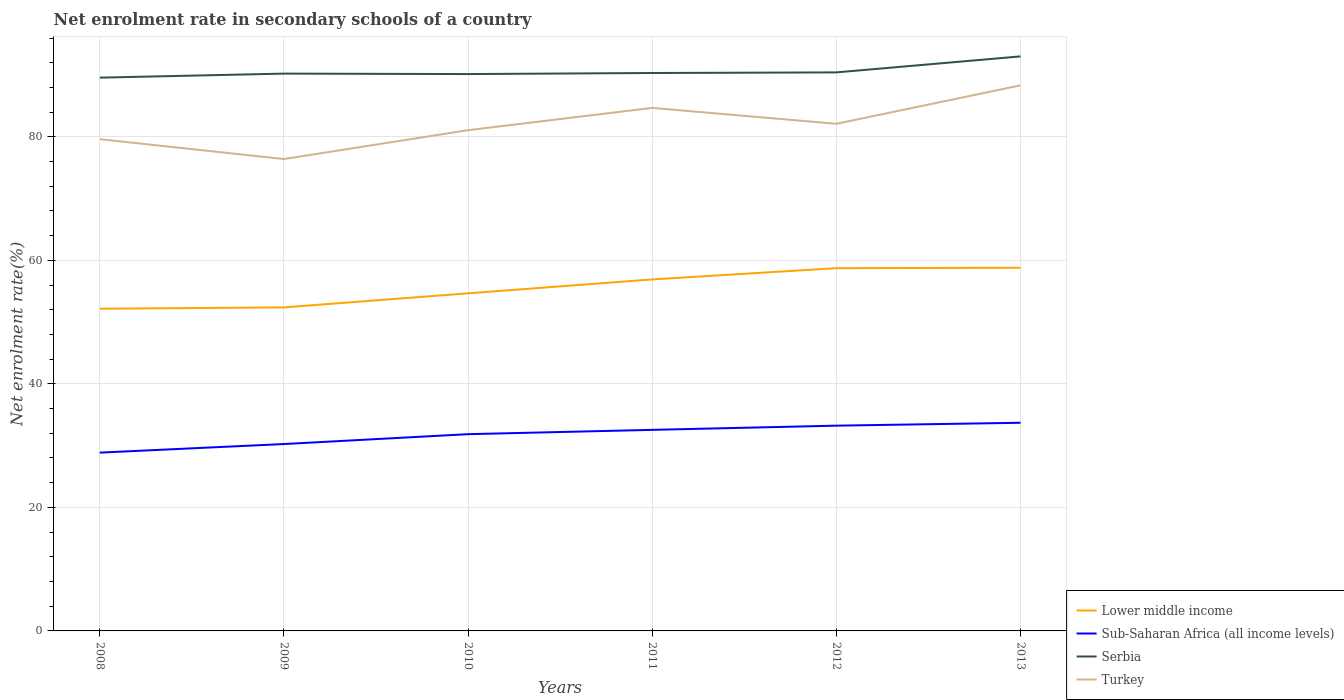Does the line corresponding to Sub-Saharan Africa (all income levels) intersect with the line corresponding to Turkey?
Offer a terse response. No. Is the number of lines equal to the number of legend labels?
Provide a short and direct response. Yes. Across all years, what is the maximum net enrolment rate in secondary schools in Sub-Saharan Africa (all income levels)?
Offer a terse response. 28.87. In which year was the net enrolment rate in secondary schools in Serbia maximum?
Make the answer very short. 2008. What is the total net enrolment rate in secondary schools in Turkey in the graph?
Ensure brevity in your answer.  -1.46. What is the difference between the highest and the second highest net enrolment rate in secondary schools in Serbia?
Offer a very short reply. 3.44. How many lines are there?
Offer a terse response. 4. How many years are there in the graph?
Ensure brevity in your answer.  6. What is the difference between two consecutive major ticks on the Y-axis?
Your response must be concise. 20. Are the values on the major ticks of Y-axis written in scientific E-notation?
Give a very brief answer. No. Does the graph contain any zero values?
Keep it short and to the point. No. How many legend labels are there?
Provide a short and direct response. 4. How are the legend labels stacked?
Ensure brevity in your answer.  Vertical. What is the title of the graph?
Your answer should be compact. Net enrolment rate in secondary schools of a country. What is the label or title of the Y-axis?
Provide a succinct answer. Net enrolment rate(%). What is the Net enrolment rate(%) in Lower middle income in 2008?
Give a very brief answer. 52.17. What is the Net enrolment rate(%) in Sub-Saharan Africa (all income levels) in 2008?
Provide a short and direct response. 28.87. What is the Net enrolment rate(%) of Serbia in 2008?
Keep it short and to the point. 89.59. What is the Net enrolment rate(%) in Turkey in 2008?
Provide a succinct answer. 79.62. What is the Net enrolment rate(%) of Lower middle income in 2009?
Your response must be concise. 52.39. What is the Net enrolment rate(%) of Sub-Saharan Africa (all income levels) in 2009?
Your response must be concise. 30.26. What is the Net enrolment rate(%) of Serbia in 2009?
Your answer should be very brief. 90.24. What is the Net enrolment rate(%) in Turkey in 2009?
Your answer should be compact. 76.41. What is the Net enrolment rate(%) in Lower middle income in 2010?
Offer a terse response. 54.67. What is the Net enrolment rate(%) in Sub-Saharan Africa (all income levels) in 2010?
Offer a very short reply. 31.86. What is the Net enrolment rate(%) of Serbia in 2010?
Your answer should be compact. 90.17. What is the Net enrolment rate(%) in Turkey in 2010?
Ensure brevity in your answer.  81.08. What is the Net enrolment rate(%) of Lower middle income in 2011?
Ensure brevity in your answer.  56.92. What is the Net enrolment rate(%) in Sub-Saharan Africa (all income levels) in 2011?
Keep it short and to the point. 32.55. What is the Net enrolment rate(%) in Serbia in 2011?
Offer a terse response. 90.34. What is the Net enrolment rate(%) of Turkey in 2011?
Your answer should be compact. 84.69. What is the Net enrolment rate(%) in Lower middle income in 2012?
Make the answer very short. 58.74. What is the Net enrolment rate(%) in Sub-Saharan Africa (all income levels) in 2012?
Ensure brevity in your answer.  33.24. What is the Net enrolment rate(%) in Serbia in 2012?
Offer a terse response. 90.44. What is the Net enrolment rate(%) of Turkey in 2012?
Make the answer very short. 82.11. What is the Net enrolment rate(%) of Lower middle income in 2013?
Make the answer very short. 58.8. What is the Net enrolment rate(%) in Sub-Saharan Africa (all income levels) in 2013?
Your answer should be very brief. 33.71. What is the Net enrolment rate(%) in Serbia in 2013?
Give a very brief answer. 93.03. What is the Net enrolment rate(%) of Turkey in 2013?
Offer a very short reply. 88.34. Across all years, what is the maximum Net enrolment rate(%) of Lower middle income?
Offer a terse response. 58.8. Across all years, what is the maximum Net enrolment rate(%) of Sub-Saharan Africa (all income levels)?
Keep it short and to the point. 33.71. Across all years, what is the maximum Net enrolment rate(%) of Serbia?
Make the answer very short. 93.03. Across all years, what is the maximum Net enrolment rate(%) of Turkey?
Your answer should be compact. 88.34. Across all years, what is the minimum Net enrolment rate(%) in Lower middle income?
Give a very brief answer. 52.17. Across all years, what is the minimum Net enrolment rate(%) of Sub-Saharan Africa (all income levels)?
Make the answer very short. 28.87. Across all years, what is the minimum Net enrolment rate(%) of Serbia?
Offer a terse response. 89.59. Across all years, what is the minimum Net enrolment rate(%) in Turkey?
Provide a short and direct response. 76.41. What is the total Net enrolment rate(%) of Lower middle income in the graph?
Provide a succinct answer. 333.68. What is the total Net enrolment rate(%) of Sub-Saharan Africa (all income levels) in the graph?
Offer a very short reply. 190.48. What is the total Net enrolment rate(%) in Serbia in the graph?
Your answer should be very brief. 543.8. What is the total Net enrolment rate(%) in Turkey in the graph?
Provide a succinct answer. 492.26. What is the difference between the Net enrolment rate(%) in Lower middle income in 2008 and that in 2009?
Your answer should be compact. -0.22. What is the difference between the Net enrolment rate(%) of Sub-Saharan Africa (all income levels) in 2008 and that in 2009?
Provide a short and direct response. -1.39. What is the difference between the Net enrolment rate(%) in Serbia in 2008 and that in 2009?
Your answer should be compact. -0.65. What is the difference between the Net enrolment rate(%) of Turkey in 2008 and that in 2009?
Provide a succinct answer. 3.22. What is the difference between the Net enrolment rate(%) in Lower middle income in 2008 and that in 2010?
Your response must be concise. -2.49. What is the difference between the Net enrolment rate(%) in Sub-Saharan Africa (all income levels) in 2008 and that in 2010?
Make the answer very short. -2.99. What is the difference between the Net enrolment rate(%) of Serbia in 2008 and that in 2010?
Ensure brevity in your answer.  -0.58. What is the difference between the Net enrolment rate(%) of Turkey in 2008 and that in 2010?
Provide a short and direct response. -1.46. What is the difference between the Net enrolment rate(%) of Lower middle income in 2008 and that in 2011?
Give a very brief answer. -4.75. What is the difference between the Net enrolment rate(%) of Sub-Saharan Africa (all income levels) in 2008 and that in 2011?
Ensure brevity in your answer.  -3.69. What is the difference between the Net enrolment rate(%) in Serbia in 2008 and that in 2011?
Provide a short and direct response. -0.75. What is the difference between the Net enrolment rate(%) of Turkey in 2008 and that in 2011?
Give a very brief answer. -5.07. What is the difference between the Net enrolment rate(%) of Lower middle income in 2008 and that in 2012?
Ensure brevity in your answer.  -6.57. What is the difference between the Net enrolment rate(%) in Sub-Saharan Africa (all income levels) in 2008 and that in 2012?
Your response must be concise. -4.37. What is the difference between the Net enrolment rate(%) of Serbia in 2008 and that in 2012?
Provide a succinct answer. -0.85. What is the difference between the Net enrolment rate(%) in Turkey in 2008 and that in 2012?
Your response must be concise. -2.49. What is the difference between the Net enrolment rate(%) in Lower middle income in 2008 and that in 2013?
Keep it short and to the point. -6.63. What is the difference between the Net enrolment rate(%) in Sub-Saharan Africa (all income levels) in 2008 and that in 2013?
Your answer should be compact. -4.84. What is the difference between the Net enrolment rate(%) in Serbia in 2008 and that in 2013?
Provide a succinct answer. -3.44. What is the difference between the Net enrolment rate(%) in Turkey in 2008 and that in 2013?
Make the answer very short. -8.72. What is the difference between the Net enrolment rate(%) in Lower middle income in 2009 and that in 2010?
Ensure brevity in your answer.  -2.28. What is the difference between the Net enrolment rate(%) in Sub-Saharan Africa (all income levels) in 2009 and that in 2010?
Offer a terse response. -1.6. What is the difference between the Net enrolment rate(%) of Serbia in 2009 and that in 2010?
Your response must be concise. 0.07. What is the difference between the Net enrolment rate(%) of Turkey in 2009 and that in 2010?
Offer a very short reply. -4.67. What is the difference between the Net enrolment rate(%) in Lower middle income in 2009 and that in 2011?
Provide a short and direct response. -4.53. What is the difference between the Net enrolment rate(%) in Sub-Saharan Africa (all income levels) in 2009 and that in 2011?
Provide a succinct answer. -2.29. What is the difference between the Net enrolment rate(%) of Serbia in 2009 and that in 2011?
Your answer should be compact. -0.1. What is the difference between the Net enrolment rate(%) of Turkey in 2009 and that in 2011?
Offer a terse response. -8.28. What is the difference between the Net enrolment rate(%) in Lower middle income in 2009 and that in 2012?
Provide a succinct answer. -6.35. What is the difference between the Net enrolment rate(%) of Sub-Saharan Africa (all income levels) in 2009 and that in 2012?
Give a very brief answer. -2.98. What is the difference between the Net enrolment rate(%) in Serbia in 2009 and that in 2012?
Give a very brief answer. -0.2. What is the difference between the Net enrolment rate(%) of Turkey in 2009 and that in 2012?
Provide a succinct answer. -5.71. What is the difference between the Net enrolment rate(%) of Lower middle income in 2009 and that in 2013?
Make the answer very short. -6.42. What is the difference between the Net enrolment rate(%) of Sub-Saharan Africa (all income levels) in 2009 and that in 2013?
Make the answer very short. -3.45. What is the difference between the Net enrolment rate(%) in Serbia in 2009 and that in 2013?
Provide a succinct answer. -2.79. What is the difference between the Net enrolment rate(%) of Turkey in 2009 and that in 2013?
Provide a short and direct response. -11.94. What is the difference between the Net enrolment rate(%) in Lower middle income in 2010 and that in 2011?
Ensure brevity in your answer.  -2.25. What is the difference between the Net enrolment rate(%) of Sub-Saharan Africa (all income levels) in 2010 and that in 2011?
Your answer should be compact. -0.7. What is the difference between the Net enrolment rate(%) in Serbia in 2010 and that in 2011?
Your response must be concise. -0.17. What is the difference between the Net enrolment rate(%) of Turkey in 2010 and that in 2011?
Offer a very short reply. -3.61. What is the difference between the Net enrolment rate(%) of Lower middle income in 2010 and that in 2012?
Keep it short and to the point. -4.07. What is the difference between the Net enrolment rate(%) of Sub-Saharan Africa (all income levels) in 2010 and that in 2012?
Your answer should be very brief. -1.38. What is the difference between the Net enrolment rate(%) of Serbia in 2010 and that in 2012?
Your response must be concise. -0.27. What is the difference between the Net enrolment rate(%) of Turkey in 2010 and that in 2012?
Your answer should be compact. -1.03. What is the difference between the Net enrolment rate(%) of Lower middle income in 2010 and that in 2013?
Keep it short and to the point. -4.14. What is the difference between the Net enrolment rate(%) in Sub-Saharan Africa (all income levels) in 2010 and that in 2013?
Ensure brevity in your answer.  -1.85. What is the difference between the Net enrolment rate(%) of Serbia in 2010 and that in 2013?
Offer a very short reply. -2.86. What is the difference between the Net enrolment rate(%) of Turkey in 2010 and that in 2013?
Your response must be concise. -7.26. What is the difference between the Net enrolment rate(%) of Lower middle income in 2011 and that in 2012?
Your answer should be very brief. -1.82. What is the difference between the Net enrolment rate(%) of Sub-Saharan Africa (all income levels) in 2011 and that in 2012?
Provide a succinct answer. -0.68. What is the difference between the Net enrolment rate(%) of Serbia in 2011 and that in 2012?
Keep it short and to the point. -0.1. What is the difference between the Net enrolment rate(%) of Turkey in 2011 and that in 2012?
Your answer should be compact. 2.58. What is the difference between the Net enrolment rate(%) of Lower middle income in 2011 and that in 2013?
Your answer should be very brief. -1.89. What is the difference between the Net enrolment rate(%) in Sub-Saharan Africa (all income levels) in 2011 and that in 2013?
Ensure brevity in your answer.  -1.15. What is the difference between the Net enrolment rate(%) in Serbia in 2011 and that in 2013?
Provide a succinct answer. -2.69. What is the difference between the Net enrolment rate(%) in Turkey in 2011 and that in 2013?
Give a very brief answer. -3.65. What is the difference between the Net enrolment rate(%) of Lower middle income in 2012 and that in 2013?
Give a very brief answer. -0.06. What is the difference between the Net enrolment rate(%) of Sub-Saharan Africa (all income levels) in 2012 and that in 2013?
Your response must be concise. -0.47. What is the difference between the Net enrolment rate(%) in Serbia in 2012 and that in 2013?
Provide a succinct answer. -2.59. What is the difference between the Net enrolment rate(%) in Turkey in 2012 and that in 2013?
Your answer should be very brief. -6.23. What is the difference between the Net enrolment rate(%) in Lower middle income in 2008 and the Net enrolment rate(%) in Sub-Saharan Africa (all income levels) in 2009?
Make the answer very short. 21.91. What is the difference between the Net enrolment rate(%) of Lower middle income in 2008 and the Net enrolment rate(%) of Serbia in 2009?
Offer a terse response. -38.07. What is the difference between the Net enrolment rate(%) in Lower middle income in 2008 and the Net enrolment rate(%) in Turkey in 2009?
Provide a succinct answer. -24.23. What is the difference between the Net enrolment rate(%) in Sub-Saharan Africa (all income levels) in 2008 and the Net enrolment rate(%) in Serbia in 2009?
Your answer should be compact. -61.37. What is the difference between the Net enrolment rate(%) of Sub-Saharan Africa (all income levels) in 2008 and the Net enrolment rate(%) of Turkey in 2009?
Your answer should be very brief. -47.54. What is the difference between the Net enrolment rate(%) of Serbia in 2008 and the Net enrolment rate(%) of Turkey in 2009?
Provide a succinct answer. 13.18. What is the difference between the Net enrolment rate(%) in Lower middle income in 2008 and the Net enrolment rate(%) in Sub-Saharan Africa (all income levels) in 2010?
Offer a very short reply. 20.31. What is the difference between the Net enrolment rate(%) in Lower middle income in 2008 and the Net enrolment rate(%) in Serbia in 2010?
Offer a very short reply. -37.99. What is the difference between the Net enrolment rate(%) of Lower middle income in 2008 and the Net enrolment rate(%) of Turkey in 2010?
Give a very brief answer. -28.91. What is the difference between the Net enrolment rate(%) of Sub-Saharan Africa (all income levels) in 2008 and the Net enrolment rate(%) of Serbia in 2010?
Offer a very short reply. -61.3. What is the difference between the Net enrolment rate(%) in Sub-Saharan Africa (all income levels) in 2008 and the Net enrolment rate(%) in Turkey in 2010?
Your answer should be very brief. -52.21. What is the difference between the Net enrolment rate(%) of Serbia in 2008 and the Net enrolment rate(%) of Turkey in 2010?
Offer a very short reply. 8.51. What is the difference between the Net enrolment rate(%) in Lower middle income in 2008 and the Net enrolment rate(%) in Sub-Saharan Africa (all income levels) in 2011?
Keep it short and to the point. 19.62. What is the difference between the Net enrolment rate(%) of Lower middle income in 2008 and the Net enrolment rate(%) of Serbia in 2011?
Your answer should be very brief. -38.17. What is the difference between the Net enrolment rate(%) of Lower middle income in 2008 and the Net enrolment rate(%) of Turkey in 2011?
Ensure brevity in your answer.  -32.52. What is the difference between the Net enrolment rate(%) of Sub-Saharan Africa (all income levels) in 2008 and the Net enrolment rate(%) of Serbia in 2011?
Offer a very short reply. -61.47. What is the difference between the Net enrolment rate(%) of Sub-Saharan Africa (all income levels) in 2008 and the Net enrolment rate(%) of Turkey in 2011?
Give a very brief answer. -55.82. What is the difference between the Net enrolment rate(%) of Serbia in 2008 and the Net enrolment rate(%) of Turkey in 2011?
Keep it short and to the point. 4.9. What is the difference between the Net enrolment rate(%) in Lower middle income in 2008 and the Net enrolment rate(%) in Sub-Saharan Africa (all income levels) in 2012?
Provide a succinct answer. 18.93. What is the difference between the Net enrolment rate(%) of Lower middle income in 2008 and the Net enrolment rate(%) of Serbia in 2012?
Offer a terse response. -38.27. What is the difference between the Net enrolment rate(%) in Lower middle income in 2008 and the Net enrolment rate(%) in Turkey in 2012?
Offer a very short reply. -29.94. What is the difference between the Net enrolment rate(%) of Sub-Saharan Africa (all income levels) in 2008 and the Net enrolment rate(%) of Serbia in 2012?
Keep it short and to the point. -61.57. What is the difference between the Net enrolment rate(%) in Sub-Saharan Africa (all income levels) in 2008 and the Net enrolment rate(%) in Turkey in 2012?
Your answer should be compact. -53.24. What is the difference between the Net enrolment rate(%) of Serbia in 2008 and the Net enrolment rate(%) of Turkey in 2012?
Your response must be concise. 7.47. What is the difference between the Net enrolment rate(%) of Lower middle income in 2008 and the Net enrolment rate(%) of Sub-Saharan Africa (all income levels) in 2013?
Your answer should be very brief. 18.47. What is the difference between the Net enrolment rate(%) in Lower middle income in 2008 and the Net enrolment rate(%) in Serbia in 2013?
Offer a terse response. -40.86. What is the difference between the Net enrolment rate(%) in Lower middle income in 2008 and the Net enrolment rate(%) in Turkey in 2013?
Ensure brevity in your answer.  -36.17. What is the difference between the Net enrolment rate(%) of Sub-Saharan Africa (all income levels) in 2008 and the Net enrolment rate(%) of Serbia in 2013?
Give a very brief answer. -64.16. What is the difference between the Net enrolment rate(%) of Sub-Saharan Africa (all income levels) in 2008 and the Net enrolment rate(%) of Turkey in 2013?
Provide a short and direct response. -59.48. What is the difference between the Net enrolment rate(%) in Serbia in 2008 and the Net enrolment rate(%) in Turkey in 2013?
Ensure brevity in your answer.  1.24. What is the difference between the Net enrolment rate(%) in Lower middle income in 2009 and the Net enrolment rate(%) in Sub-Saharan Africa (all income levels) in 2010?
Provide a short and direct response. 20.53. What is the difference between the Net enrolment rate(%) of Lower middle income in 2009 and the Net enrolment rate(%) of Serbia in 2010?
Your answer should be very brief. -37.78. What is the difference between the Net enrolment rate(%) in Lower middle income in 2009 and the Net enrolment rate(%) in Turkey in 2010?
Your answer should be compact. -28.69. What is the difference between the Net enrolment rate(%) in Sub-Saharan Africa (all income levels) in 2009 and the Net enrolment rate(%) in Serbia in 2010?
Your answer should be very brief. -59.91. What is the difference between the Net enrolment rate(%) of Sub-Saharan Africa (all income levels) in 2009 and the Net enrolment rate(%) of Turkey in 2010?
Make the answer very short. -50.82. What is the difference between the Net enrolment rate(%) of Serbia in 2009 and the Net enrolment rate(%) of Turkey in 2010?
Offer a terse response. 9.16. What is the difference between the Net enrolment rate(%) in Lower middle income in 2009 and the Net enrolment rate(%) in Sub-Saharan Africa (all income levels) in 2011?
Provide a succinct answer. 19.83. What is the difference between the Net enrolment rate(%) in Lower middle income in 2009 and the Net enrolment rate(%) in Serbia in 2011?
Your response must be concise. -37.95. What is the difference between the Net enrolment rate(%) of Lower middle income in 2009 and the Net enrolment rate(%) of Turkey in 2011?
Provide a succinct answer. -32.3. What is the difference between the Net enrolment rate(%) of Sub-Saharan Africa (all income levels) in 2009 and the Net enrolment rate(%) of Serbia in 2011?
Provide a succinct answer. -60.08. What is the difference between the Net enrolment rate(%) in Sub-Saharan Africa (all income levels) in 2009 and the Net enrolment rate(%) in Turkey in 2011?
Your answer should be very brief. -54.43. What is the difference between the Net enrolment rate(%) of Serbia in 2009 and the Net enrolment rate(%) of Turkey in 2011?
Give a very brief answer. 5.55. What is the difference between the Net enrolment rate(%) in Lower middle income in 2009 and the Net enrolment rate(%) in Sub-Saharan Africa (all income levels) in 2012?
Offer a terse response. 19.15. What is the difference between the Net enrolment rate(%) of Lower middle income in 2009 and the Net enrolment rate(%) of Serbia in 2012?
Make the answer very short. -38.05. What is the difference between the Net enrolment rate(%) in Lower middle income in 2009 and the Net enrolment rate(%) in Turkey in 2012?
Give a very brief answer. -29.73. What is the difference between the Net enrolment rate(%) of Sub-Saharan Africa (all income levels) in 2009 and the Net enrolment rate(%) of Serbia in 2012?
Your answer should be very brief. -60.18. What is the difference between the Net enrolment rate(%) in Sub-Saharan Africa (all income levels) in 2009 and the Net enrolment rate(%) in Turkey in 2012?
Give a very brief answer. -51.85. What is the difference between the Net enrolment rate(%) of Serbia in 2009 and the Net enrolment rate(%) of Turkey in 2012?
Your response must be concise. 8.13. What is the difference between the Net enrolment rate(%) of Lower middle income in 2009 and the Net enrolment rate(%) of Sub-Saharan Africa (all income levels) in 2013?
Make the answer very short. 18.68. What is the difference between the Net enrolment rate(%) in Lower middle income in 2009 and the Net enrolment rate(%) in Serbia in 2013?
Provide a short and direct response. -40.64. What is the difference between the Net enrolment rate(%) in Lower middle income in 2009 and the Net enrolment rate(%) in Turkey in 2013?
Your answer should be compact. -35.96. What is the difference between the Net enrolment rate(%) of Sub-Saharan Africa (all income levels) in 2009 and the Net enrolment rate(%) of Serbia in 2013?
Offer a terse response. -62.77. What is the difference between the Net enrolment rate(%) of Sub-Saharan Africa (all income levels) in 2009 and the Net enrolment rate(%) of Turkey in 2013?
Give a very brief answer. -58.08. What is the difference between the Net enrolment rate(%) of Serbia in 2009 and the Net enrolment rate(%) of Turkey in 2013?
Offer a very short reply. 1.9. What is the difference between the Net enrolment rate(%) in Lower middle income in 2010 and the Net enrolment rate(%) in Sub-Saharan Africa (all income levels) in 2011?
Your answer should be very brief. 22.11. What is the difference between the Net enrolment rate(%) of Lower middle income in 2010 and the Net enrolment rate(%) of Serbia in 2011?
Offer a very short reply. -35.67. What is the difference between the Net enrolment rate(%) of Lower middle income in 2010 and the Net enrolment rate(%) of Turkey in 2011?
Make the answer very short. -30.02. What is the difference between the Net enrolment rate(%) in Sub-Saharan Africa (all income levels) in 2010 and the Net enrolment rate(%) in Serbia in 2011?
Ensure brevity in your answer.  -58.48. What is the difference between the Net enrolment rate(%) of Sub-Saharan Africa (all income levels) in 2010 and the Net enrolment rate(%) of Turkey in 2011?
Give a very brief answer. -52.83. What is the difference between the Net enrolment rate(%) in Serbia in 2010 and the Net enrolment rate(%) in Turkey in 2011?
Provide a short and direct response. 5.48. What is the difference between the Net enrolment rate(%) in Lower middle income in 2010 and the Net enrolment rate(%) in Sub-Saharan Africa (all income levels) in 2012?
Provide a short and direct response. 21.43. What is the difference between the Net enrolment rate(%) in Lower middle income in 2010 and the Net enrolment rate(%) in Serbia in 2012?
Give a very brief answer. -35.77. What is the difference between the Net enrolment rate(%) of Lower middle income in 2010 and the Net enrolment rate(%) of Turkey in 2012?
Your response must be concise. -27.45. What is the difference between the Net enrolment rate(%) in Sub-Saharan Africa (all income levels) in 2010 and the Net enrolment rate(%) in Serbia in 2012?
Give a very brief answer. -58.58. What is the difference between the Net enrolment rate(%) in Sub-Saharan Africa (all income levels) in 2010 and the Net enrolment rate(%) in Turkey in 2012?
Your response must be concise. -50.25. What is the difference between the Net enrolment rate(%) in Serbia in 2010 and the Net enrolment rate(%) in Turkey in 2012?
Your answer should be compact. 8.05. What is the difference between the Net enrolment rate(%) in Lower middle income in 2010 and the Net enrolment rate(%) in Sub-Saharan Africa (all income levels) in 2013?
Provide a short and direct response. 20.96. What is the difference between the Net enrolment rate(%) of Lower middle income in 2010 and the Net enrolment rate(%) of Serbia in 2013?
Your answer should be compact. -38.36. What is the difference between the Net enrolment rate(%) in Lower middle income in 2010 and the Net enrolment rate(%) in Turkey in 2013?
Give a very brief answer. -33.68. What is the difference between the Net enrolment rate(%) of Sub-Saharan Africa (all income levels) in 2010 and the Net enrolment rate(%) of Serbia in 2013?
Offer a terse response. -61.17. What is the difference between the Net enrolment rate(%) in Sub-Saharan Africa (all income levels) in 2010 and the Net enrolment rate(%) in Turkey in 2013?
Offer a terse response. -56.49. What is the difference between the Net enrolment rate(%) of Serbia in 2010 and the Net enrolment rate(%) of Turkey in 2013?
Your response must be concise. 1.82. What is the difference between the Net enrolment rate(%) of Lower middle income in 2011 and the Net enrolment rate(%) of Sub-Saharan Africa (all income levels) in 2012?
Give a very brief answer. 23.68. What is the difference between the Net enrolment rate(%) of Lower middle income in 2011 and the Net enrolment rate(%) of Serbia in 2012?
Make the answer very short. -33.52. What is the difference between the Net enrolment rate(%) in Lower middle income in 2011 and the Net enrolment rate(%) in Turkey in 2012?
Ensure brevity in your answer.  -25.2. What is the difference between the Net enrolment rate(%) in Sub-Saharan Africa (all income levels) in 2011 and the Net enrolment rate(%) in Serbia in 2012?
Your response must be concise. -57.88. What is the difference between the Net enrolment rate(%) of Sub-Saharan Africa (all income levels) in 2011 and the Net enrolment rate(%) of Turkey in 2012?
Your answer should be compact. -49.56. What is the difference between the Net enrolment rate(%) of Serbia in 2011 and the Net enrolment rate(%) of Turkey in 2012?
Make the answer very short. 8.23. What is the difference between the Net enrolment rate(%) of Lower middle income in 2011 and the Net enrolment rate(%) of Sub-Saharan Africa (all income levels) in 2013?
Provide a succinct answer. 23.21. What is the difference between the Net enrolment rate(%) of Lower middle income in 2011 and the Net enrolment rate(%) of Serbia in 2013?
Make the answer very short. -36.11. What is the difference between the Net enrolment rate(%) in Lower middle income in 2011 and the Net enrolment rate(%) in Turkey in 2013?
Your answer should be compact. -31.43. What is the difference between the Net enrolment rate(%) in Sub-Saharan Africa (all income levels) in 2011 and the Net enrolment rate(%) in Serbia in 2013?
Offer a terse response. -60.47. What is the difference between the Net enrolment rate(%) of Sub-Saharan Africa (all income levels) in 2011 and the Net enrolment rate(%) of Turkey in 2013?
Make the answer very short. -55.79. What is the difference between the Net enrolment rate(%) in Serbia in 2011 and the Net enrolment rate(%) in Turkey in 2013?
Make the answer very short. 1.99. What is the difference between the Net enrolment rate(%) in Lower middle income in 2012 and the Net enrolment rate(%) in Sub-Saharan Africa (all income levels) in 2013?
Your response must be concise. 25.03. What is the difference between the Net enrolment rate(%) of Lower middle income in 2012 and the Net enrolment rate(%) of Serbia in 2013?
Keep it short and to the point. -34.29. What is the difference between the Net enrolment rate(%) in Lower middle income in 2012 and the Net enrolment rate(%) in Turkey in 2013?
Provide a short and direct response. -29.61. What is the difference between the Net enrolment rate(%) in Sub-Saharan Africa (all income levels) in 2012 and the Net enrolment rate(%) in Serbia in 2013?
Offer a very short reply. -59.79. What is the difference between the Net enrolment rate(%) in Sub-Saharan Africa (all income levels) in 2012 and the Net enrolment rate(%) in Turkey in 2013?
Ensure brevity in your answer.  -55.11. What is the difference between the Net enrolment rate(%) of Serbia in 2012 and the Net enrolment rate(%) of Turkey in 2013?
Keep it short and to the point. 2.09. What is the average Net enrolment rate(%) in Lower middle income per year?
Your answer should be compact. 55.61. What is the average Net enrolment rate(%) of Sub-Saharan Africa (all income levels) per year?
Provide a short and direct response. 31.75. What is the average Net enrolment rate(%) in Serbia per year?
Provide a succinct answer. 90.63. What is the average Net enrolment rate(%) of Turkey per year?
Your response must be concise. 82.04. In the year 2008, what is the difference between the Net enrolment rate(%) in Lower middle income and Net enrolment rate(%) in Sub-Saharan Africa (all income levels)?
Your answer should be very brief. 23.3. In the year 2008, what is the difference between the Net enrolment rate(%) in Lower middle income and Net enrolment rate(%) in Serbia?
Keep it short and to the point. -37.42. In the year 2008, what is the difference between the Net enrolment rate(%) in Lower middle income and Net enrolment rate(%) in Turkey?
Make the answer very short. -27.45. In the year 2008, what is the difference between the Net enrolment rate(%) in Sub-Saharan Africa (all income levels) and Net enrolment rate(%) in Serbia?
Your answer should be very brief. -60.72. In the year 2008, what is the difference between the Net enrolment rate(%) of Sub-Saharan Africa (all income levels) and Net enrolment rate(%) of Turkey?
Your answer should be very brief. -50.76. In the year 2008, what is the difference between the Net enrolment rate(%) of Serbia and Net enrolment rate(%) of Turkey?
Offer a terse response. 9.96. In the year 2009, what is the difference between the Net enrolment rate(%) in Lower middle income and Net enrolment rate(%) in Sub-Saharan Africa (all income levels)?
Make the answer very short. 22.13. In the year 2009, what is the difference between the Net enrolment rate(%) of Lower middle income and Net enrolment rate(%) of Serbia?
Provide a short and direct response. -37.85. In the year 2009, what is the difference between the Net enrolment rate(%) of Lower middle income and Net enrolment rate(%) of Turkey?
Give a very brief answer. -24.02. In the year 2009, what is the difference between the Net enrolment rate(%) of Sub-Saharan Africa (all income levels) and Net enrolment rate(%) of Serbia?
Make the answer very short. -59.98. In the year 2009, what is the difference between the Net enrolment rate(%) in Sub-Saharan Africa (all income levels) and Net enrolment rate(%) in Turkey?
Offer a very short reply. -46.15. In the year 2009, what is the difference between the Net enrolment rate(%) in Serbia and Net enrolment rate(%) in Turkey?
Your answer should be compact. 13.84. In the year 2010, what is the difference between the Net enrolment rate(%) of Lower middle income and Net enrolment rate(%) of Sub-Saharan Africa (all income levels)?
Your answer should be very brief. 22.81. In the year 2010, what is the difference between the Net enrolment rate(%) of Lower middle income and Net enrolment rate(%) of Serbia?
Your response must be concise. -35.5. In the year 2010, what is the difference between the Net enrolment rate(%) of Lower middle income and Net enrolment rate(%) of Turkey?
Your answer should be very brief. -26.41. In the year 2010, what is the difference between the Net enrolment rate(%) of Sub-Saharan Africa (all income levels) and Net enrolment rate(%) of Serbia?
Your answer should be very brief. -58.31. In the year 2010, what is the difference between the Net enrolment rate(%) in Sub-Saharan Africa (all income levels) and Net enrolment rate(%) in Turkey?
Make the answer very short. -49.22. In the year 2010, what is the difference between the Net enrolment rate(%) of Serbia and Net enrolment rate(%) of Turkey?
Offer a terse response. 9.09. In the year 2011, what is the difference between the Net enrolment rate(%) of Lower middle income and Net enrolment rate(%) of Sub-Saharan Africa (all income levels)?
Your answer should be very brief. 24.36. In the year 2011, what is the difference between the Net enrolment rate(%) in Lower middle income and Net enrolment rate(%) in Serbia?
Your answer should be very brief. -33.42. In the year 2011, what is the difference between the Net enrolment rate(%) in Lower middle income and Net enrolment rate(%) in Turkey?
Provide a short and direct response. -27.77. In the year 2011, what is the difference between the Net enrolment rate(%) in Sub-Saharan Africa (all income levels) and Net enrolment rate(%) in Serbia?
Make the answer very short. -57.78. In the year 2011, what is the difference between the Net enrolment rate(%) of Sub-Saharan Africa (all income levels) and Net enrolment rate(%) of Turkey?
Give a very brief answer. -52.13. In the year 2011, what is the difference between the Net enrolment rate(%) of Serbia and Net enrolment rate(%) of Turkey?
Keep it short and to the point. 5.65. In the year 2012, what is the difference between the Net enrolment rate(%) in Lower middle income and Net enrolment rate(%) in Sub-Saharan Africa (all income levels)?
Your answer should be compact. 25.5. In the year 2012, what is the difference between the Net enrolment rate(%) of Lower middle income and Net enrolment rate(%) of Serbia?
Keep it short and to the point. -31.7. In the year 2012, what is the difference between the Net enrolment rate(%) in Lower middle income and Net enrolment rate(%) in Turkey?
Ensure brevity in your answer.  -23.38. In the year 2012, what is the difference between the Net enrolment rate(%) in Sub-Saharan Africa (all income levels) and Net enrolment rate(%) in Serbia?
Offer a very short reply. -57.2. In the year 2012, what is the difference between the Net enrolment rate(%) of Sub-Saharan Africa (all income levels) and Net enrolment rate(%) of Turkey?
Your answer should be very brief. -48.88. In the year 2012, what is the difference between the Net enrolment rate(%) in Serbia and Net enrolment rate(%) in Turkey?
Your answer should be very brief. 8.33. In the year 2013, what is the difference between the Net enrolment rate(%) in Lower middle income and Net enrolment rate(%) in Sub-Saharan Africa (all income levels)?
Offer a terse response. 25.1. In the year 2013, what is the difference between the Net enrolment rate(%) of Lower middle income and Net enrolment rate(%) of Serbia?
Provide a succinct answer. -34.23. In the year 2013, what is the difference between the Net enrolment rate(%) of Lower middle income and Net enrolment rate(%) of Turkey?
Ensure brevity in your answer.  -29.54. In the year 2013, what is the difference between the Net enrolment rate(%) in Sub-Saharan Africa (all income levels) and Net enrolment rate(%) in Serbia?
Your answer should be very brief. -59.32. In the year 2013, what is the difference between the Net enrolment rate(%) in Sub-Saharan Africa (all income levels) and Net enrolment rate(%) in Turkey?
Your answer should be compact. -54.64. In the year 2013, what is the difference between the Net enrolment rate(%) of Serbia and Net enrolment rate(%) of Turkey?
Offer a very short reply. 4.68. What is the ratio of the Net enrolment rate(%) of Sub-Saharan Africa (all income levels) in 2008 to that in 2009?
Offer a very short reply. 0.95. What is the ratio of the Net enrolment rate(%) of Turkey in 2008 to that in 2009?
Keep it short and to the point. 1.04. What is the ratio of the Net enrolment rate(%) of Lower middle income in 2008 to that in 2010?
Your answer should be compact. 0.95. What is the ratio of the Net enrolment rate(%) in Sub-Saharan Africa (all income levels) in 2008 to that in 2010?
Your answer should be very brief. 0.91. What is the ratio of the Net enrolment rate(%) in Serbia in 2008 to that in 2010?
Your answer should be very brief. 0.99. What is the ratio of the Net enrolment rate(%) of Lower middle income in 2008 to that in 2011?
Your answer should be compact. 0.92. What is the ratio of the Net enrolment rate(%) in Sub-Saharan Africa (all income levels) in 2008 to that in 2011?
Offer a very short reply. 0.89. What is the ratio of the Net enrolment rate(%) in Serbia in 2008 to that in 2011?
Your response must be concise. 0.99. What is the ratio of the Net enrolment rate(%) in Turkey in 2008 to that in 2011?
Your answer should be very brief. 0.94. What is the ratio of the Net enrolment rate(%) of Lower middle income in 2008 to that in 2012?
Offer a terse response. 0.89. What is the ratio of the Net enrolment rate(%) in Sub-Saharan Africa (all income levels) in 2008 to that in 2012?
Provide a succinct answer. 0.87. What is the ratio of the Net enrolment rate(%) in Serbia in 2008 to that in 2012?
Your response must be concise. 0.99. What is the ratio of the Net enrolment rate(%) in Turkey in 2008 to that in 2012?
Make the answer very short. 0.97. What is the ratio of the Net enrolment rate(%) in Lower middle income in 2008 to that in 2013?
Provide a succinct answer. 0.89. What is the ratio of the Net enrolment rate(%) in Sub-Saharan Africa (all income levels) in 2008 to that in 2013?
Ensure brevity in your answer.  0.86. What is the ratio of the Net enrolment rate(%) in Turkey in 2008 to that in 2013?
Offer a very short reply. 0.9. What is the ratio of the Net enrolment rate(%) in Sub-Saharan Africa (all income levels) in 2009 to that in 2010?
Your answer should be very brief. 0.95. What is the ratio of the Net enrolment rate(%) in Turkey in 2009 to that in 2010?
Offer a very short reply. 0.94. What is the ratio of the Net enrolment rate(%) in Lower middle income in 2009 to that in 2011?
Provide a short and direct response. 0.92. What is the ratio of the Net enrolment rate(%) of Sub-Saharan Africa (all income levels) in 2009 to that in 2011?
Your answer should be very brief. 0.93. What is the ratio of the Net enrolment rate(%) in Serbia in 2009 to that in 2011?
Offer a terse response. 1. What is the ratio of the Net enrolment rate(%) of Turkey in 2009 to that in 2011?
Ensure brevity in your answer.  0.9. What is the ratio of the Net enrolment rate(%) in Lower middle income in 2009 to that in 2012?
Offer a very short reply. 0.89. What is the ratio of the Net enrolment rate(%) of Sub-Saharan Africa (all income levels) in 2009 to that in 2012?
Give a very brief answer. 0.91. What is the ratio of the Net enrolment rate(%) in Turkey in 2009 to that in 2012?
Your answer should be very brief. 0.93. What is the ratio of the Net enrolment rate(%) in Lower middle income in 2009 to that in 2013?
Make the answer very short. 0.89. What is the ratio of the Net enrolment rate(%) in Sub-Saharan Africa (all income levels) in 2009 to that in 2013?
Your response must be concise. 0.9. What is the ratio of the Net enrolment rate(%) in Serbia in 2009 to that in 2013?
Make the answer very short. 0.97. What is the ratio of the Net enrolment rate(%) in Turkey in 2009 to that in 2013?
Make the answer very short. 0.86. What is the ratio of the Net enrolment rate(%) in Lower middle income in 2010 to that in 2011?
Your answer should be very brief. 0.96. What is the ratio of the Net enrolment rate(%) of Sub-Saharan Africa (all income levels) in 2010 to that in 2011?
Make the answer very short. 0.98. What is the ratio of the Net enrolment rate(%) in Turkey in 2010 to that in 2011?
Provide a short and direct response. 0.96. What is the ratio of the Net enrolment rate(%) in Lower middle income in 2010 to that in 2012?
Your answer should be compact. 0.93. What is the ratio of the Net enrolment rate(%) of Sub-Saharan Africa (all income levels) in 2010 to that in 2012?
Offer a terse response. 0.96. What is the ratio of the Net enrolment rate(%) of Turkey in 2010 to that in 2012?
Your answer should be very brief. 0.99. What is the ratio of the Net enrolment rate(%) in Lower middle income in 2010 to that in 2013?
Ensure brevity in your answer.  0.93. What is the ratio of the Net enrolment rate(%) in Sub-Saharan Africa (all income levels) in 2010 to that in 2013?
Make the answer very short. 0.95. What is the ratio of the Net enrolment rate(%) in Serbia in 2010 to that in 2013?
Provide a short and direct response. 0.97. What is the ratio of the Net enrolment rate(%) in Turkey in 2010 to that in 2013?
Ensure brevity in your answer.  0.92. What is the ratio of the Net enrolment rate(%) of Sub-Saharan Africa (all income levels) in 2011 to that in 2012?
Your answer should be compact. 0.98. What is the ratio of the Net enrolment rate(%) in Turkey in 2011 to that in 2012?
Your answer should be compact. 1.03. What is the ratio of the Net enrolment rate(%) in Lower middle income in 2011 to that in 2013?
Give a very brief answer. 0.97. What is the ratio of the Net enrolment rate(%) of Sub-Saharan Africa (all income levels) in 2011 to that in 2013?
Give a very brief answer. 0.97. What is the ratio of the Net enrolment rate(%) in Serbia in 2011 to that in 2013?
Your answer should be very brief. 0.97. What is the ratio of the Net enrolment rate(%) of Turkey in 2011 to that in 2013?
Keep it short and to the point. 0.96. What is the ratio of the Net enrolment rate(%) of Lower middle income in 2012 to that in 2013?
Provide a short and direct response. 1. What is the ratio of the Net enrolment rate(%) in Sub-Saharan Africa (all income levels) in 2012 to that in 2013?
Keep it short and to the point. 0.99. What is the ratio of the Net enrolment rate(%) in Serbia in 2012 to that in 2013?
Give a very brief answer. 0.97. What is the ratio of the Net enrolment rate(%) in Turkey in 2012 to that in 2013?
Keep it short and to the point. 0.93. What is the difference between the highest and the second highest Net enrolment rate(%) of Lower middle income?
Provide a succinct answer. 0.06. What is the difference between the highest and the second highest Net enrolment rate(%) of Sub-Saharan Africa (all income levels)?
Provide a succinct answer. 0.47. What is the difference between the highest and the second highest Net enrolment rate(%) in Serbia?
Your response must be concise. 2.59. What is the difference between the highest and the second highest Net enrolment rate(%) in Turkey?
Ensure brevity in your answer.  3.65. What is the difference between the highest and the lowest Net enrolment rate(%) of Lower middle income?
Keep it short and to the point. 6.63. What is the difference between the highest and the lowest Net enrolment rate(%) of Sub-Saharan Africa (all income levels)?
Make the answer very short. 4.84. What is the difference between the highest and the lowest Net enrolment rate(%) in Serbia?
Provide a succinct answer. 3.44. What is the difference between the highest and the lowest Net enrolment rate(%) in Turkey?
Provide a short and direct response. 11.94. 